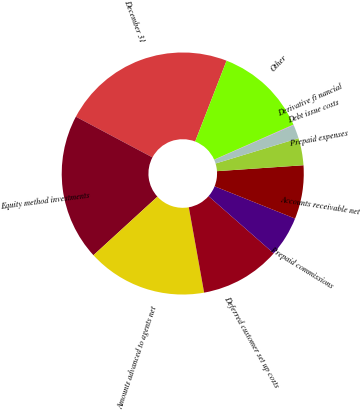Convert chart. <chart><loc_0><loc_0><loc_500><loc_500><pie_chart><fcel>December 31<fcel>Equity method investments<fcel>Amounts advanced to agents net<fcel>Deferred customer set up costs<fcel>Prepaid commissions<fcel>Accounts receivable net<fcel>Prepaid expenses<fcel>Debt issue costs<fcel>Derivative fi nancial<fcel>Other<nl><fcel>23.12%<fcel>19.57%<fcel>16.03%<fcel>10.71%<fcel>5.39%<fcel>7.16%<fcel>3.62%<fcel>1.84%<fcel>0.07%<fcel>12.48%<nl></chart> 